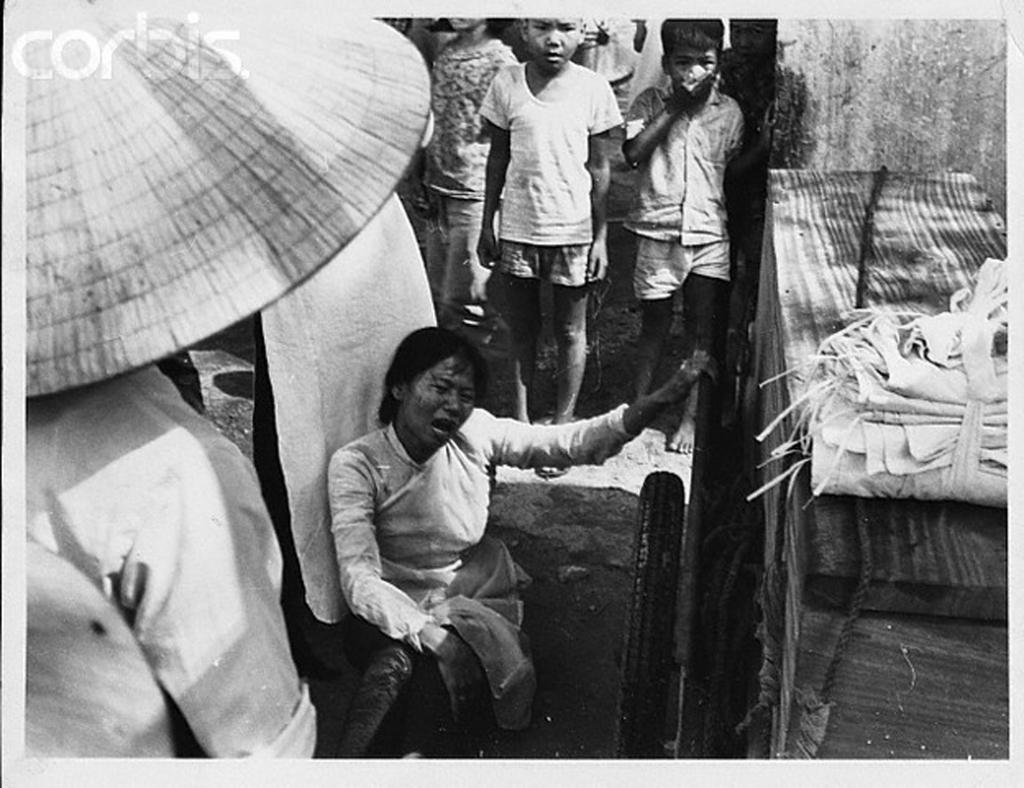Could you give a brief overview of what you see in this image? This is a black and white image where we can see this woman sitting on the ground and these children are standing here. Here we can see a cart on which we can see a wooden box is kept on it. Here we can see a person standing on their head we can see a hat is kept. Here we can see a watermark at the top left side of the image. 